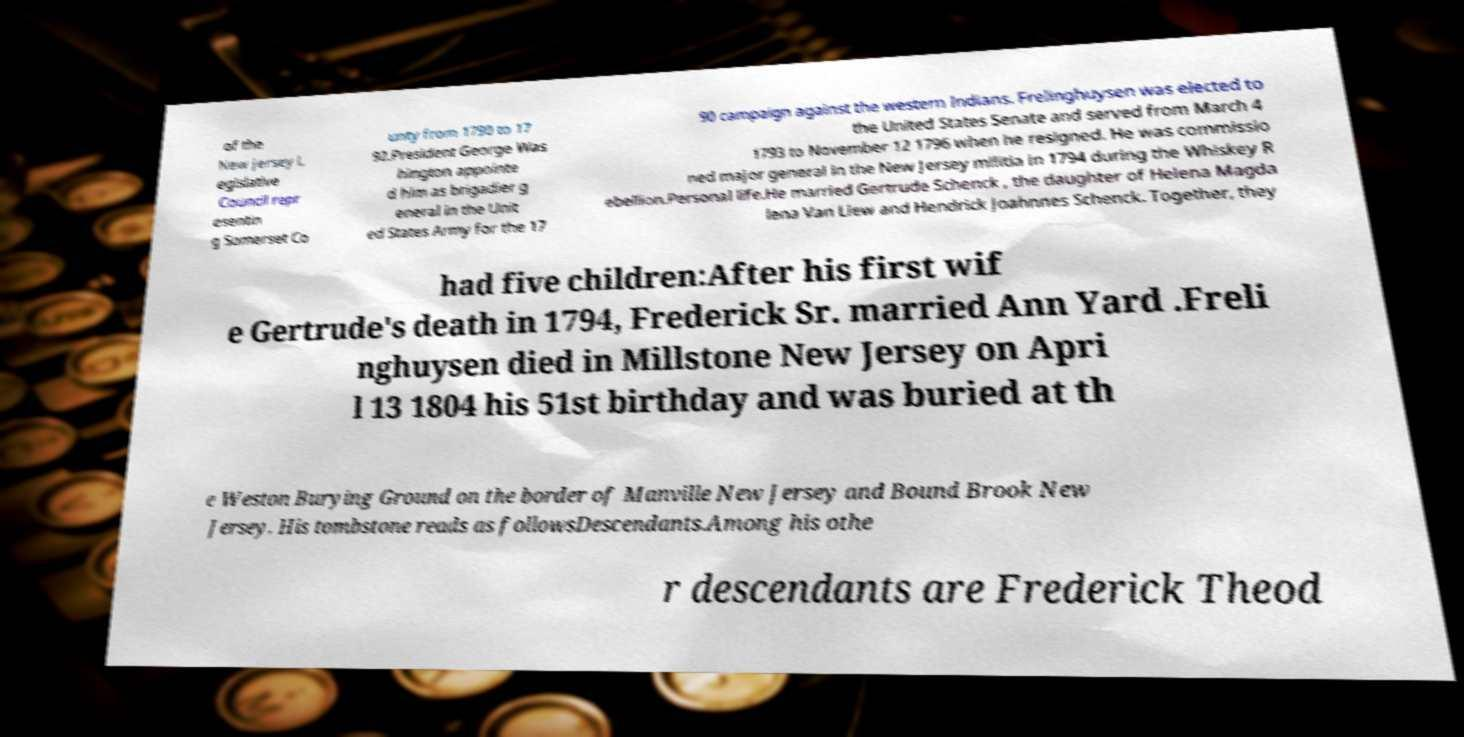Can you read and provide the text displayed in the image?This photo seems to have some interesting text. Can you extract and type it out for me? of the New Jersey L egislative Council repr esentin g Somerset Co unty from 1790 to 17 92.President George Was hington appointe d him as brigadier g eneral in the Unit ed States Army for the 17 90 campaign against the western Indians. Frelinghuysen was elected to the United States Senate and served from March 4 1793 to November 12 1796 when he resigned. He was commissio ned major general in the New Jersey militia in 1794 during the Whiskey R ebellion.Personal life.He married Gertrude Schenck , the daughter of Helena Magda lena Van Liew and Hendrick Joahnnes Schenck. Together, they had five children:After his first wif e Gertrude's death in 1794, Frederick Sr. married Ann Yard .Freli nghuysen died in Millstone New Jersey on Apri l 13 1804 his 51st birthday and was buried at th e Weston Burying Ground on the border of Manville New Jersey and Bound Brook New Jersey. His tombstone reads as followsDescendants.Among his othe r descendants are Frederick Theod 